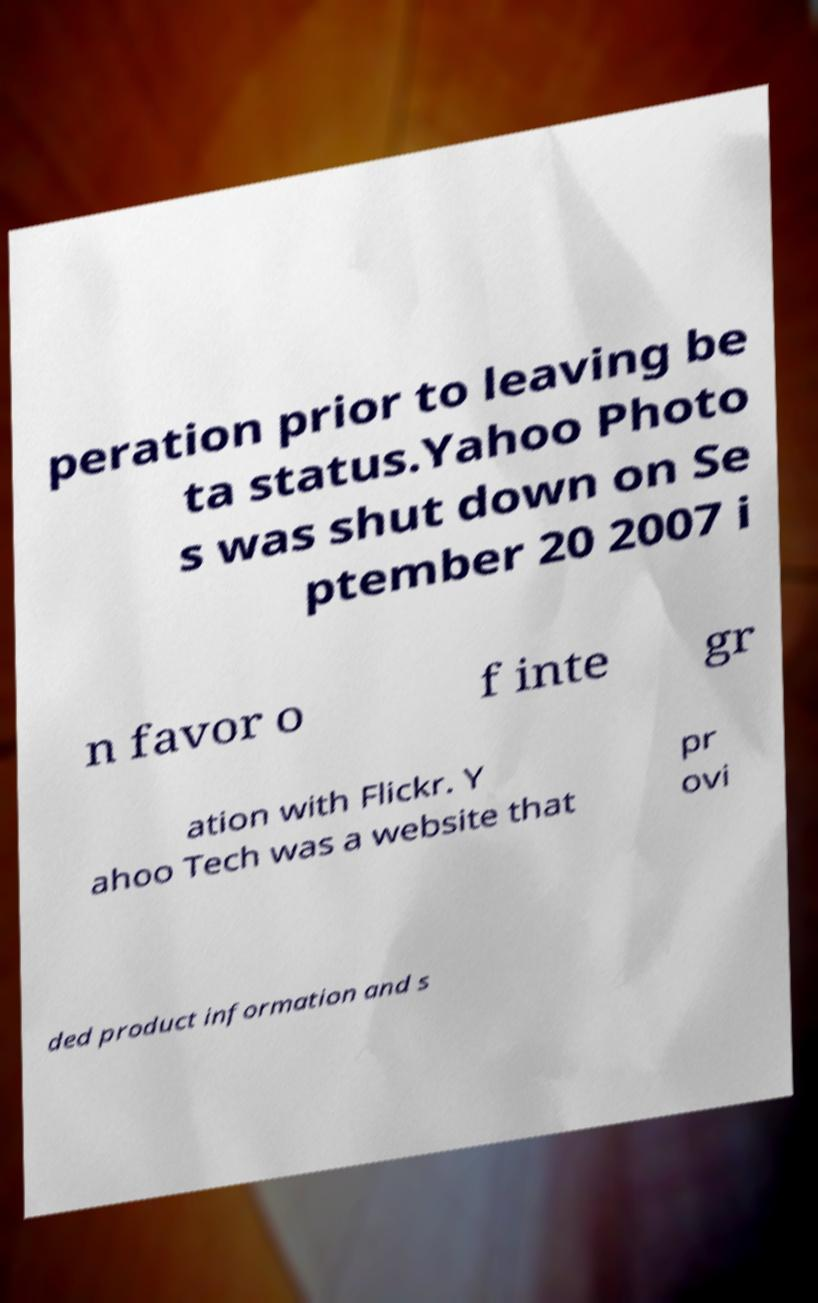Can you read and provide the text displayed in the image?This photo seems to have some interesting text. Can you extract and type it out for me? peration prior to leaving be ta status.Yahoo Photo s was shut down on Se ptember 20 2007 i n favor o f inte gr ation with Flickr. Y ahoo Tech was a website that pr ovi ded product information and s 